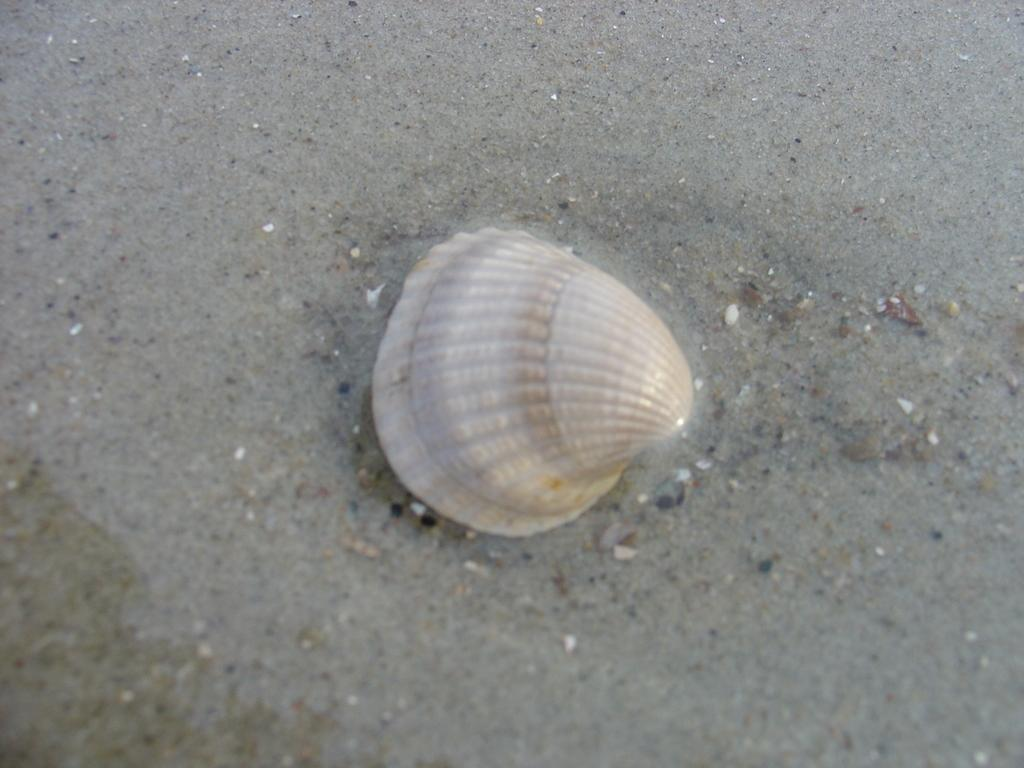What object can be seen in the picture? There is a shell in the picture. Where is the shell located? The shell is on the sand. What is the color of the shell? The shell is white in color. Are there any cacti visible in the picture? There is no mention of cacti in the provided facts, so we cannot determine if any are present in the image. 